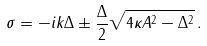<formula> <loc_0><loc_0><loc_500><loc_500>\sigma = - i k \Delta \pm \frac { \Delta } { 2 } \sqrt { 4 \kappa A ^ { 2 } - \Delta ^ { 2 } } \, .</formula> 